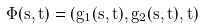Convert formula to latex. <formula><loc_0><loc_0><loc_500><loc_500>\label p a r { e q \colon r a n k } \Phi ( s , t ) = ( g _ { 1 } ( s , t ) , g _ { 2 } ( s , t ) , t )</formula> 